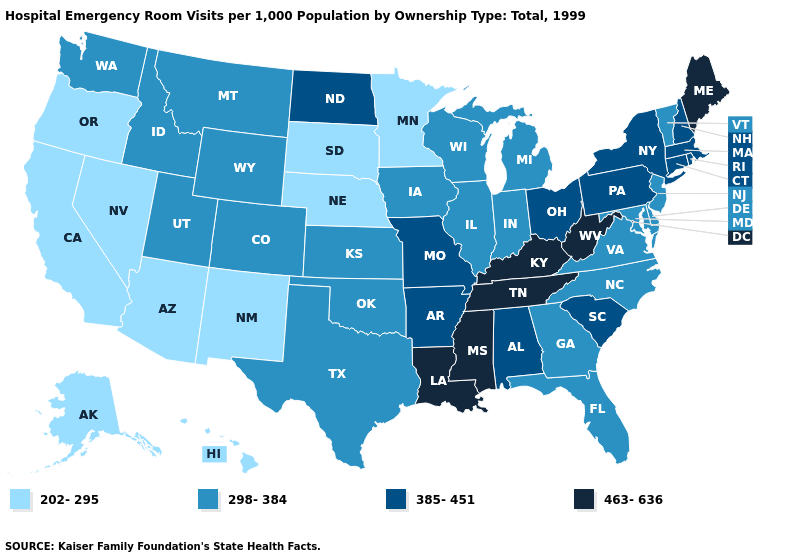What is the value of Ohio?
Short answer required. 385-451. Is the legend a continuous bar?
Be succinct. No. Which states have the lowest value in the Northeast?
Quick response, please. New Jersey, Vermont. Does Colorado have the highest value in the West?
Quick response, please. Yes. What is the lowest value in the West?
Write a very short answer. 202-295. What is the lowest value in the South?
Keep it brief. 298-384. Does Massachusetts have a higher value than Rhode Island?
Keep it brief. No. Name the states that have a value in the range 463-636?
Concise answer only. Kentucky, Louisiana, Maine, Mississippi, Tennessee, West Virginia. What is the value of Arkansas?
Short answer required. 385-451. Which states have the lowest value in the USA?
Write a very short answer. Alaska, Arizona, California, Hawaii, Minnesota, Nebraska, Nevada, New Mexico, Oregon, South Dakota. Name the states that have a value in the range 463-636?
Short answer required. Kentucky, Louisiana, Maine, Mississippi, Tennessee, West Virginia. What is the highest value in the USA?
Concise answer only. 463-636. What is the value of Maine?
Give a very brief answer. 463-636. Name the states that have a value in the range 463-636?
Concise answer only. Kentucky, Louisiana, Maine, Mississippi, Tennessee, West Virginia. 